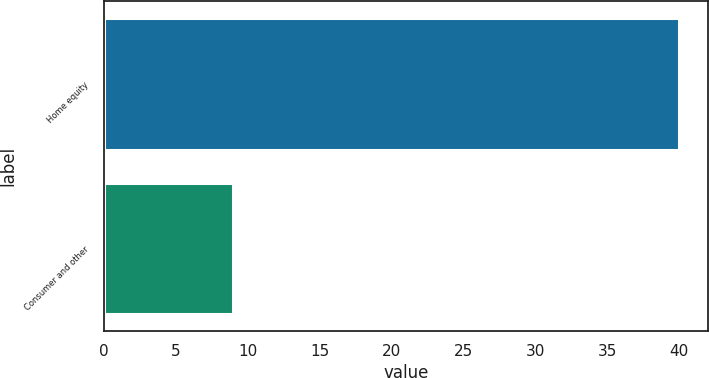Convert chart to OTSL. <chart><loc_0><loc_0><loc_500><loc_500><bar_chart><fcel>Home equity<fcel>Consumer and other<nl><fcel>40<fcel>9<nl></chart> 